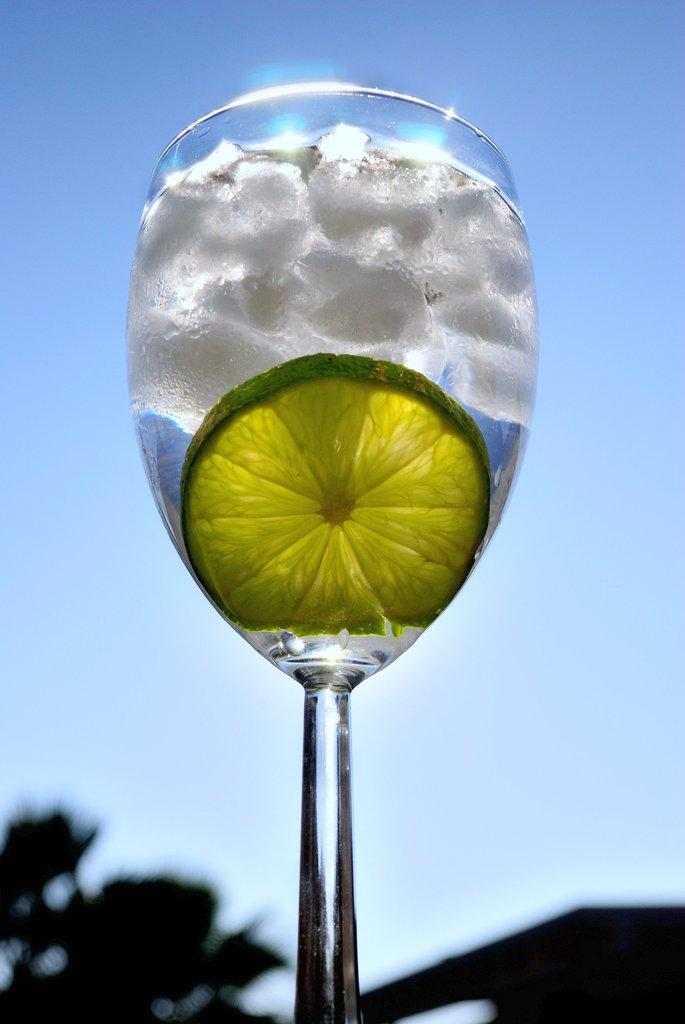What is floating in the water in the image? There are ice pieces and an orange piece in the water. What is the water contained in? The water is in a glass. What can be seen in the background of the image? There is a blue sky and other objects visible in the background. What type of silver material is present in the image? There is no silver material present in the image. What kind of arch can be seen in the background of the image? There is no arch visible in the background of the image. 